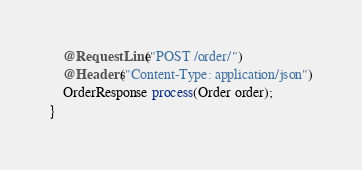<code> <loc_0><loc_0><loc_500><loc_500><_Java_>    @RequestLine("POST /order/")
    @Headers("Content-Type: application/json")
    OrderResponse process(Order order);
}
</code> 